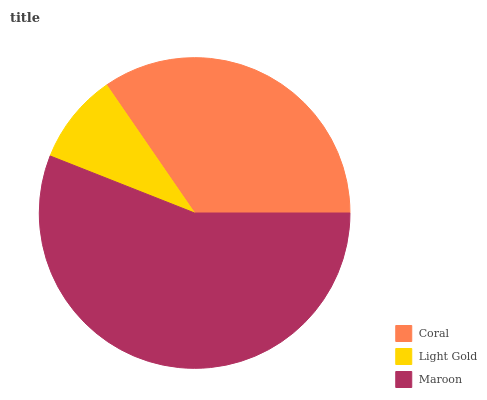Is Light Gold the minimum?
Answer yes or no. Yes. Is Maroon the maximum?
Answer yes or no. Yes. Is Maroon the minimum?
Answer yes or no. No. Is Light Gold the maximum?
Answer yes or no. No. Is Maroon greater than Light Gold?
Answer yes or no. Yes. Is Light Gold less than Maroon?
Answer yes or no. Yes. Is Light Gold greater than Maroon?
Answer yes or no. No. Is Maroon less than Light Gold?
Answer yes or no. No. Is Coral the high median?
Answer yes or no. Yes. Is Coral the low median?
Answer yes or no. Yes. Is Light Gold the high median?
Answer yes or no. No. Is Maroon the low median?
Answer yes or no. No. 